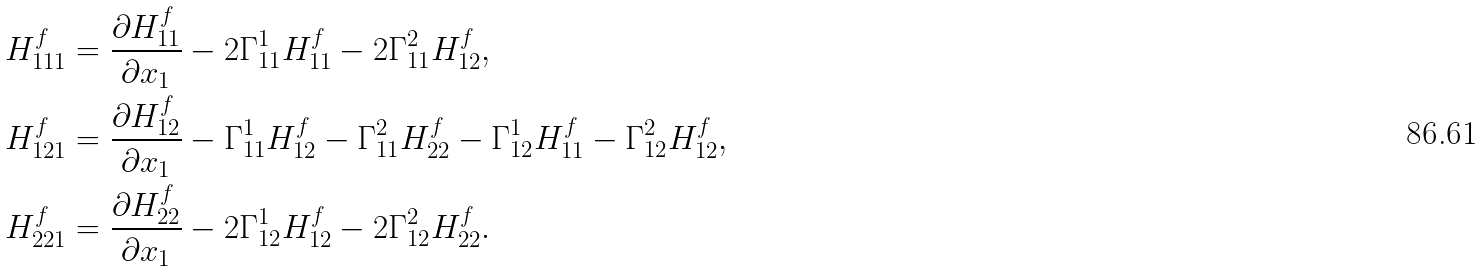<formula> <loc_0><loc_0><loc_500><loc_500>& H ^ { f } _ { 1 1 1 } = \frac { \partial H ^ { f } _ { 1 1 } } { \partial x _ { 1 } } - 2 \Gamma ^ { 1 } _ { 1 1 } H ^ { f } _ { 1 1 } - 2 \Gamma ^ { 2 } _ { 1 1 } H ^ { f } _ { 1 2 } , \\ & H ^ { f } _ { 1 2 1 } = \frac { \partial H ^ { f } _ { 1 2 } } { \partial x _ { 1 } } - \Gamma ^ { 1 } _ { 1 1 } H ^ { f } _ { 1 2 } - \Gamma ^ { 2 } _ { 1 1 } H ^ { f } _ { 2 2 } - \Gamma ^ { 1 } _ { 1 2 } H ^ { f } _ { 1 1 } - \Gamma ^ { 2 } _ { 1 2 } H ^ { f } _ { 1 2 } , \\ & H ^ { f } _ { 2 2 1 } = \frac { \partial H ^ { f } _ { 2 2 } } { \partial x _ { 1 } } - 2 \Gamma ^ { 1 } _ { 1 2 } H ^ { f } _ { 1 2 } - 2 \Gamma ^ { 2 } _ { 1 2 } H ^ { f } _ { 2 2 } .</formula> 